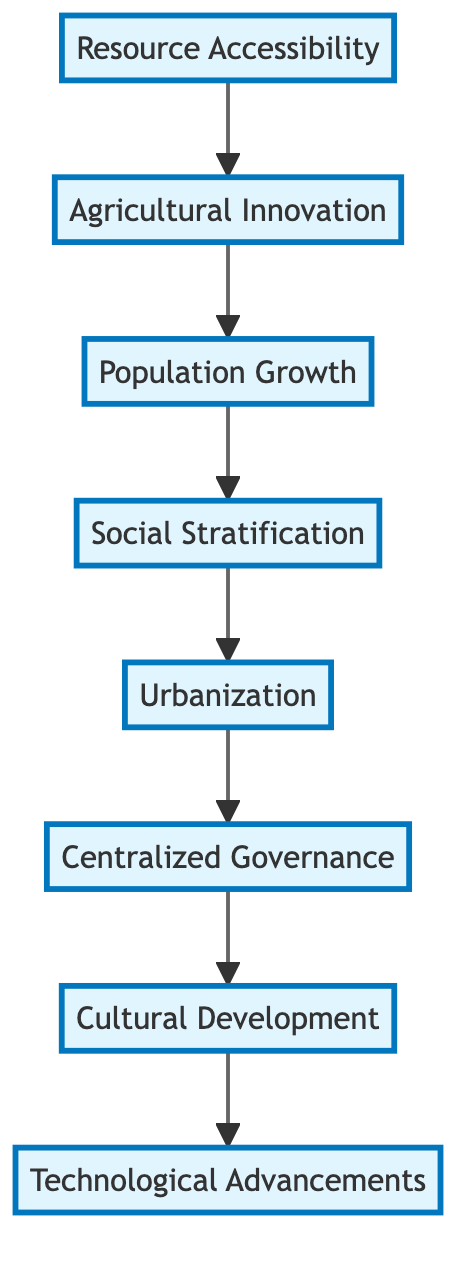What is the first stage in the development process? The first stage in the development process is "Resource Accessibility," which appears at the top of the flow chart.
Answer: Resource Accessibility How many total stages are represented in the diagram? The diagram contains eight stages, as listed from top to bottom in the flowchart.
Answer: 8 Which stage directly follows Urbanization? Following "Urbanization," the next stage is "Centralized Governance," as indicated by the direct arrow connecting them in the flowchart.
Answer: Centralized Governance What is the last stage of development in the flow chart? The last stage of development is "Technological Advancements," which is shown at the bottom of the flowchart, indicating the final stage in the process.
Answer: Technological Advancements Which two stages are connected by the arrow from Agricultural Innovation? The "Agricultural Innovation" stage leads directly to "Population Growth," as depicted by the arrow that connects these two stages in the diagram.
Answer: Population Growth What does Social Stratification lead to? "Social Stratification" leads to "Urbanization," according to the flow connection shown in the diagram.
Answer: Urbanization What is one of the main characteristics of Cultural Development? "Cultural Development" is characterized by the emergence of distinct cultural practices, which is a key element mentioned in its description within the chart.
Answer: Distinct cultural practices Which stage is associated with the formation of social classes? The stage associated with the formation of social classes is "Social Stratification," as specifically stated in its description within the flowchart.
Answer: Social Stratification Which two factors collectively contribute to the establishment of Centralized Governance? "Urbanization" and "Social Stratification" directly lead to the establishment of "Centralized Governance," as they are the two stages that connect to it in the flow.
Answer: Urbanization and Social Stratification 